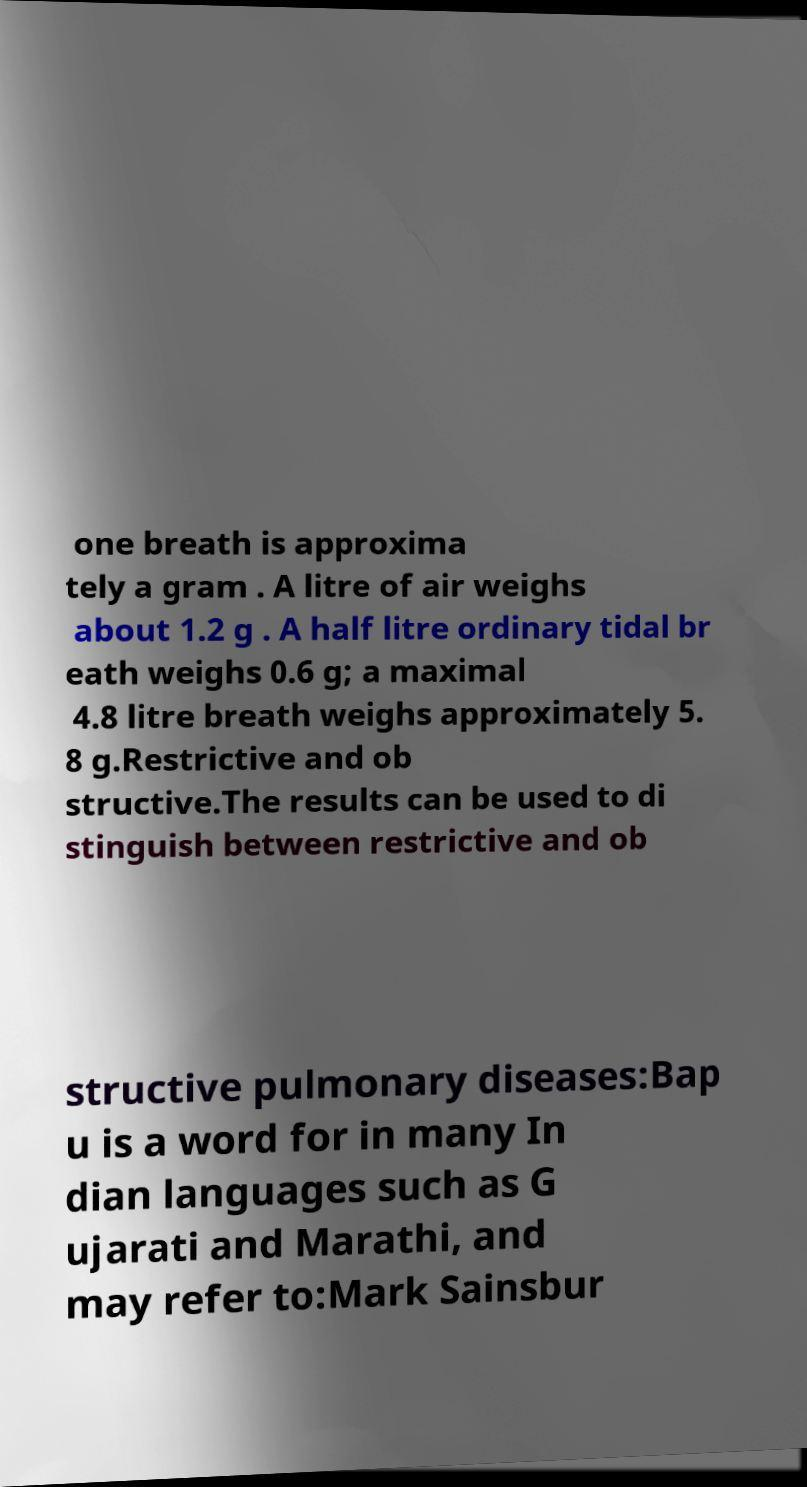Please identify and transcribe the text found in this image. one breath is approxima tely a gram . A litre of air weighs about 1.2 g . A half litre ordinary tidal br eath weighs 0.6 g; a maximal 4.8 litre breath weighs approximately 5. 8 g.Restrictive and ob structive.The results can be used to di stinguish between restrictive and ob structive pulmonary diseases:Bap u is a word for in many In dian languages such as G ujarati and Marathi, and may refer to:Mark Sainsbur 